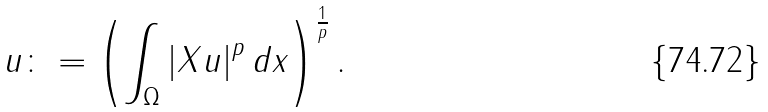Convert formula to latex. <formula><loc_0><loc_0><loc_500><loc_500>\| u \| \colon = \left ( \int _ { \Omega } \left | X u \right | ^ { p } d x \right ) ^ { \frac { 1 } { p } } .</formula> 